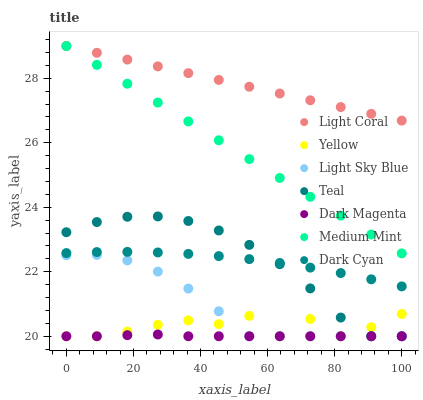Does Dark Magenta have the minimum area under the curve?
Answer yes or no. Yes. Does Light Coral have the maximum area under the curve?
Answer yes or no. Yes. Does Yellow have the minimum area under the curve?
Answer yes or no. No. Does Yellow have the maximum area under the curve?
Answer yes or no. No. Is Light Coral the smoothest?
Answer yes or no. Yes. Is Yellow the roughest?
Answer yes or no. Yes. Is Dark Magenta the smoothest?
Answer yes or no. No. Is Dark Magenta the roughest?
Answer yes or no. No. Does Dark Magenta have the lowest value?
Answer yes or no. Yes. Does Light Coral have the lowest value?
Answer yes or no. No. Does Light Coral have the highest value?
Answer yes or no. Yes. Does Yellow have the highest value?
Answer yes or no. No. Is Yellow less than Medium Mint?
Answer yes or no. Yes. Is Dark Cyan greater than Yellow?
Answer yes or no. Yes. Does Dark Magenta intersect Light Sky Blue?
Answer yes or no. Yes. Is Dark Magenta less than Light Sky Blue?
Answer yes or no. No. Is Dark Magenta greater than Light Sky Blue?
Answer yes or no. No. Does Yellow intersect Medium Mint?
Answer yes or no. No. 